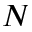<formula> <loc_0><loc_0><loc_500><loc_500>N</formula> 